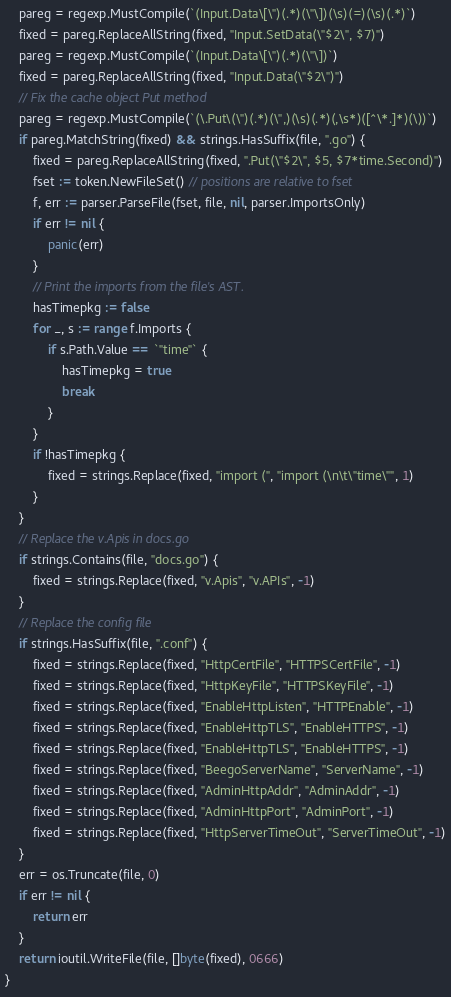<code> <loc_0><loc_0><loc_500><loc_500><_Go_>	pareg = regexp.MustCompile(`(Input.Data\[\")(.*)(\"\])(\s)(=)(\s)(.*)`)
	fixed = pareg.ReplaceAllString(fixed, "Input.SetData(\"$2\", $7)")
	pareg = regexp.MustCompile(`(Input.Data\[\")(.*)(\"\])`)
	fixed = pareg.ReplaceAllString(fixed, "Input.Data(\"$2\")")
	// Fix the cache object Put method
	pareg = regexp.MustCompile(`(\.Put\(\")(.*)(\",)(\s)(.*)(,\s*)([^\*.]*)(\))`)
	if pareg.MatchString(fixed) && strings.HasSuffix(file, ".go") {
		fixed = pareg.ReplaceAllString(fixed, ".Put(\"$2\", $5, $7*time.Second)")
		fset := token.NewFileSet() // positions are relative to fset
		f, err := parser.ParseFile(fset, file, nil, parser.ImportsOnly)
		if err != nil {
			panic(err)
		}
		// Print the imports from the file's AST.
		hasTimepkg := false
		for _, s := range f.Imports {
			if s.Path.Value == `"time"` {
				hasTimepkg = true
				break
			}
		}
		if !hasTimepkg {
			fixed = strings.Replace(fixed, "import (", "import (\n\t\"time\"", 1)
		}
	}
	// Replace the v.Apis in docs.go
	if strings.Contains(file, "docs.go") {
		fixed = strings.Replace(fixed, "v.Apis", "v.APIs", -1)
	}
	// Replace the config file
	if strings.HasSuffix(file, ".conf") {
		fixed = strings.Replace(fixed, "HttpCertFile", "HTTPSCertFile", -1)
		fixed = strings.Replace(fixed, "HttpKeyFile", "HTTPSKeyFile", -1)
		fixed = strings.Replace(fixed, "EnableHttpListen", "HTTPEnable", -1)
		fixed = strings.Replace(fixed, "EnableHttpTLS", "EnableHTTPS", -1)
		fixed = strings.Replace(fixed, "EnableHttpTLS", "EnableHTTPS", -1)
		fixed = strings.Replace(fixed, "BeegoServerName", "ServerName", -1)
		fixed = strings.Replace(fixed, "AdminHttpAddr", "AdminAddr", -1)
		fixed = strings.Replace(fixed, "AdminHttpPort", "AdminPort", -1)
		fixed = strings.Replace(fixed, "HttpServerTimeOut", "ServerTimeOut", -1)
	}
	err = os.Truncate(file, 0)
	if err != nil {
		return err
	}
	return ioutil.WriteFile(file, []byte(fixed), 0666)
}
</code> 